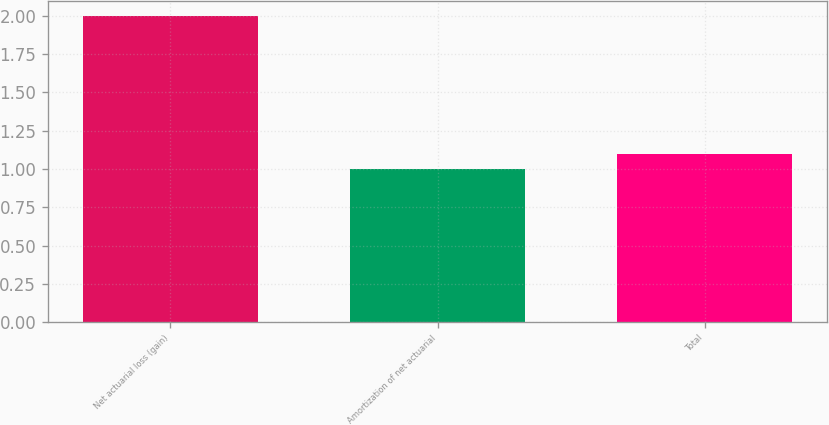Convert chart to OTSL. <chart><loc_0><loc_0><loc_500><loc_500><bar_chart><fcel>Net actuarial loss (gain)<fcel>Amortization of net actuarial<fcel>Total<nl><fcel>2<fcel>1<fcel>1.1<nl></chart> 